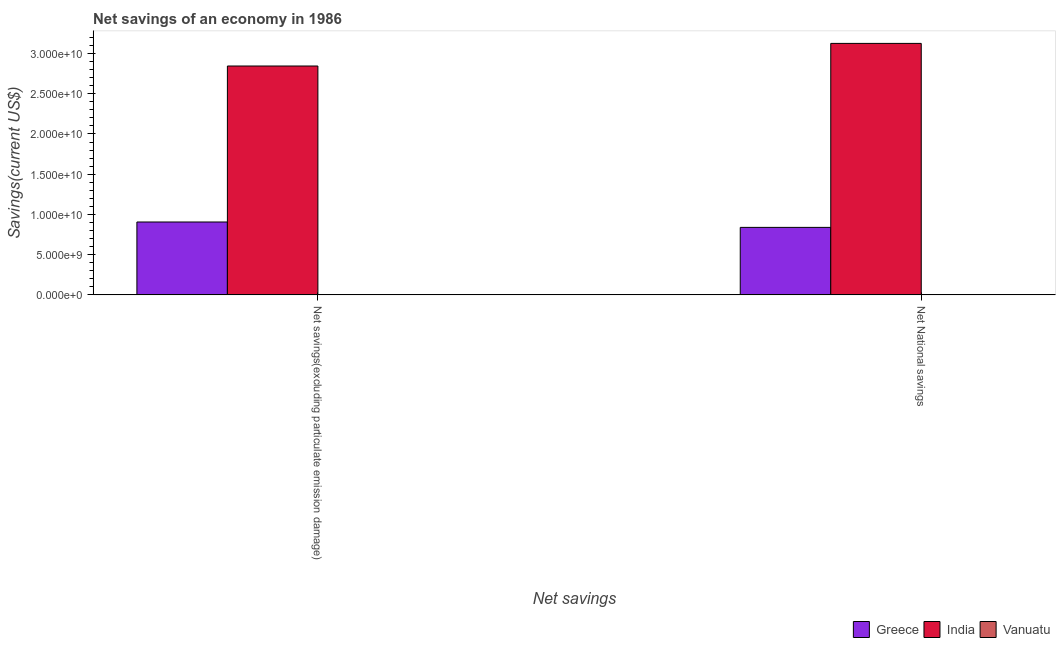How many different coloured bars are there?
Offer a very short reply. 3. How many groups of bars are there?
Provide a succinct answer. 2. How many bars are there on the 1st tick from the left?
Ensure brevity in your answer.  3. How many bars are there on the 1st tick from the right?
Keep it short and to the point. 3. What is the label of the 1st group of bars from the left?
Make the answer very short. Net savings(excluding particulate emission damage). What is the net national savings in India?
Provide a short and direct response. 3.13e+1. Across all countries, what is the maximum net national savings?
Offer a very short reply. 3.13e+1. Across all countries, what is the minimum net national savings?
Offer a terse response. 8.86e+06. In which country was the net savings(excluding particulate emission damage) maximum?
Your response must be concise. India. In which country was the net national savings minimum?
Your answer should be very brief. Vanuatu. What is the total net national savings in the graph?
Provide a short and direct response. 3.97e+1. What is the difference between the net national savings in Greece and that in India?
Offer a very short reply. -2.29e+1. What is the difference between the net savings(excluding particulate emission damage) in Greece and the net national savings in Vanuatu?
Make the answer very short. 9.05e+09. What is the average net savings(excluding particulate emission damage) per country?
Offer a very short reply. 1.25e+1. What is the difference between the net national savings and net savings(excluding particulate emission damage) in Vanuatu?
Provide a succinct answer. -8.53e+06. In how many countries, is the net savings(excluding particulate emission damage) greater than 21000000000 US$?
Ensure brevity in your answer.  1. What is the ratio of the net national savings in Vanuatu to that in India?
Ensure brevity in your answer.  0. What does the 2nd bar from the right in Net savings(excluding particulate emission damage) represents?
Give a very brief answer. India. Are all the bars in the graph horizontal?
Your answer should be very brief. No. What is the difference between two consecutive major ticks on the Y-axis?
Your answer should be compact. 5.00e+09. Where does the legend appear in the graph?
Your answer should be very brief. Bottom right. How many legend labels are there?
Keep it short and to the point. 3. What is the title of the graph?
Provide a succinct answer. Net savings of an economy in 1986. Does "Moldova" appear as one of the legend labels in the graph?
Offer a terse response. No. What is the label or title of the X-axis?
Your response must be concise. Net savings. What is the label or title of the Y-axis?
Your answer should be compact. Savings(current US$). What is the Savings(current US$) in Greece in Net savings(excluding particulate emission damage)?
Keep it short and to the point. 9.06e+09. What is the Savings(current US$) of India in Net savings(excluding particulate emission damage)?
Give a very brief answer. 2.85e+1. What is the Savings(current US$) in Vanuatu in Net savings(excluding particulate emission damage)?
Provide a short and direct response. 1.74e+07. What is the Savings(current US$) in Greece in Net National savings?
Offer a terse response. 8.39e+09. What is the Savings(current US$) of India in Net National savings?
Ensure brevity in your answer.  3.13e+1. What is the Savings(current US$) of Vanuatu in Net National savings?
Keep it short and to the point. 8.86e+06. Across all Net savings, what is the maximum Savings(current US$) of Greece?
Provide a succinct answer. 9.06e+09. Across all Net savings, what is the maximum Savings(current US$) in India?
Offer a terse response. 3.13e+1. Across all Net savings, what is the maximum Savings(current US$) in Vanuatu?
Keep it short and to the point. 1.74e+07. Across all Net savings, what is the minimum Savings(current US$) in Greece?
Your answer should be compact. 8.39e+09. Across all Net savings, what is the minimum Savings(current US$) in India?
Your answer should be very brief. 2.85e+1. Across all Net savings, what is the minimum Savings(current US$) of Vanuatu?
Provide a short and direct response. 8.86e+06. What is the total Savings(current US$) in Greece in the graph?
Offer a very short reply. 1.75e+1. What is the total Savings(current US$) of India in the graph?
Offer a very short reply. 5.97e+1. What is the total Savings(current US$) in Vanuatu in the graph?
Keep it short and to the point. 2.63e+07. What is the difference between the Savings(current US$) in Greece in Net savings(excluding particulate emission damage) and that in Net National savings?
Keep it short and to the point. 6.69e+08. What is the difference between the Savings(current US$) in India in Net savings(excluding particulate emission damage) and that in Net National savings?
Ensure brevity in your answer.  -2.81e+09. What is the difference between the Savings(current US$) in Vanuatu in Net savings(excluding particulate emission damage) and that in Net National savings?
Your answer should be compact. 8.53e+06. What is the difference between the Savings(current US$) in Greece in Net savings(excluding particulate emission damage) and the Savings(current US$) in India in Net National savings?
Make the answer very short. -2.22e+1. What is the difference between the Savings(current US$) in Greece in Net savings(excluding particulate emission damage) and the Savings(current US$) in Vanuatu in Net National savings?
Offer a very short reply. 9.05e+09. What is the difference between the Savings(current US$) of India in Net savings(excluding particulate emission damage) and the Savings(current US$) of Vanuatu in Net National savings?
Ensure brevity in your answer.  2.84e+1. What is the average Savings(current US$) in Greece per Net savings?
Make the answer very short. 8.73e+09. What is the average Savings(current US$) in India per Net savings?
Provide a short and direct response. 2.99e+1. What is the average Savings(current US$) in Vanuatu per Net savings?
Give a very brief answer. 1.31e+07. What is the difference between the Savings(current US$) of Greece and Savings(current US$) of India in Net savings(excluding particulate emission damage)?
Provide a short and direct response. -1.94e+1. What is the difference between the Savings(current US$) in Greece and Savings(current US$) in Vanuatu in Net savings(excluding particulate emission damage)?
Offer a very short reply. 9.04e+09. What is the difference between the Savings(current US$) of India and Savings(current US$) of Vanuatu in Net savings(excluding particulate emission damage)?
Ensure brevity in your answer.  2.84e+1. What is the difference between the Savings(current US$) in Greece and Savings(current US$) in India in Net National savings?
Keep it short and to the point. -2.29e+1. What is the difference between the Savings(current US$) in Greece and Savings(current US$) in Vanuatu in Net National savings?
Keep it short and to the point. 8.38e+09. What is the difference between the Savings(current US$) of India and Savings(current US$) of Vanuatu in Net National savings?
Your answer should be very brief. 3.13e+1. What is the ratio of the Savings(current US$) of Greece in Net savings(excluding particulate emission damage) to that in Net National savings?
Provide a short and direct response. 1.08. What is the ratio of the Savings(current US$) in India in Net savings(excluding particulate emission damage) to that in Net National savings?
Your response must be concise. 0.91. What is the ratio of the Savings(current US$) of Vanuatu in Net savings(excluding particulate emission damage) to that in Net National savings?
Make the answer very short. 1.96. What is the difference between the highest and the second highest Savings(current US$) of Greece?
Offer a very short reply. 6.69e+08. What is the difference between the highest and the second highest Savings(current US$) in India?
Your answer should be compact. 2.81e+09. What is the difference between the highest and the second highest Savings(current US$) in Vanuatu?
Offer a very short reply. 8.53e+06. What is the difference between the highest and the lowest Savings(current US$) of Greece?
Offer a terse response. 6.69e+08. What is the difference between the highest and the lowest Savings(current US$) in India?
Make the answer very short. 2.81e+09. What is the difference between the highest and the lowest Savings(current US$) in Vanuatu?
Make the answer very short. 8.53e+06. 